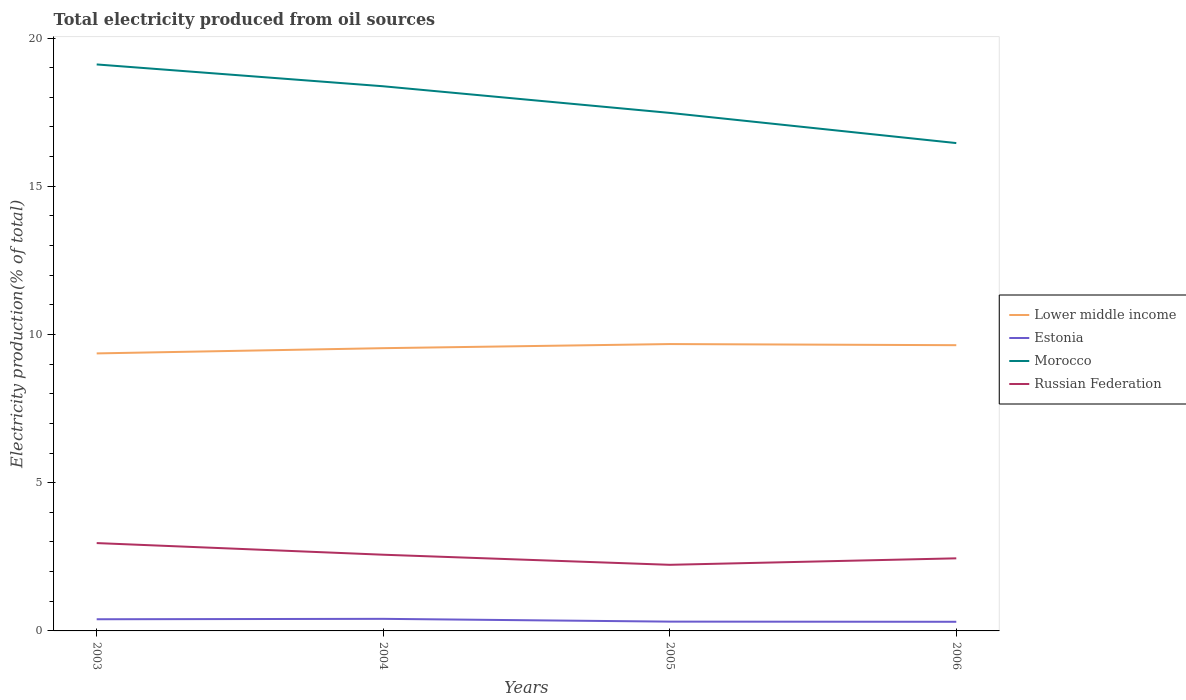Is the number of lines equal to the number of legend labels?
Offer a very short reply. Yes. Across all years, what is the maximum total electricity produced in Lower middle income?
Ensure brevity in your answer.  9.36. In which year was the total electricity produced in Estonia maximum?
Offer a terse response. 2006. What is the total total electricity produced in Russian Federation in the graph?
Ensure brevity in your answer.  -0.22. What is the difference between the highest and the second highest total electricity produced in Morocco?
Give a very brief answer. 2.65. What is the difference between the highest and the lowest total electricity produced in Morocco?
Ensure brevity in your answer.  2. Is the total electricity produced in Morocco strictly greater than the total electricity produced in Russian Federation over the years?
Your answer should be very brief. No. How many years are there in the graph?
Provide a succinct answer. 4. What is the difference between two consecutive major ticks on the Y-axis?
Provide a succinct answer. 5. Are the values on the major ticks of Y-axis written in scientific E-notation?
Keep it short and to the point. No. Does the graph contain any zero values?
Keep it short and to the point. No. Does the graph contain grids?
Provide a short and direct response. No. Where does the legend appear in the graph?
Offer a very short reply. Center right. How many legend labels are there?
Offer a very short reply. 4. What is the title of the graph?
Make the answer very short. Total electricity produced from oil sources. What is the Electricity production(% of total) in Lower middle income in 2003?
Provide a short and direct response. 9.36. What is the Electricity production(% of total) of Estonia in 2003?
Provide a short and direct response. 0.39. What is the Electricity production(% of total) of Morocco in 2003?
Offer a very short reply. 19.11. What is the Electricity production(% of total) in Russian Federation in 2003?
Make the answer very short. 2.96. What is the Electricity production(% of total) in Lower middle income in 2004?
Provide a short and direct response. 9.54. What is the Electricity production(% of total) of Estonia in 2004?
Make the answer very short. 0.41. What is the Electricity production(% of total) of Morocco in 2004?
Ensure brevity in your answer.  18.37. What is the Electricity production(% of total) in Russian Federation in 2004?
Your answer should be very brief. 2.57. What is the Electricity production(% of total) of Lower middle income in 2005?
Offer a terse response. 9.68. What is the Electricity production(% of total) of Estonia in 2005?
Your answer should be very brief. 0.31. What is the Electricity production(% of total) in Morocco in 2005?
Your answer should be compact. 17.48. What is the Electricity production(% of total) in Russian Federation in 2005?
Keep it short and to the point. 2.23. What is the Electricity production(% of total) in Lower middle income in 2006?
Your answer should be compact. 9.64. What is the Electricity production(% of total) in Estonia in 2006?
Make the answer very short. 0.31. What is the Electricity production(% of total) of Morocco in 2006?
Your response must be concise. 16.46. What is the Electricity production(% of total) of Russian Federation in 2006?
Provide a short and direct response. 2.45. Across all years, what is the maximum Electricity production(% of total) of Lower middle income?
Keep it short and to the point. 9.68. Across all years, what is the maximum Electricity production(% of total) of Estonia?
Ensure brevity in your answer.  0.41. Across all years, what is the maximum Electricity production(% of total) of Morocco?
Give a very brief answer. 19.11. Across all years, what is the maximum Electricity production(% of total) of Russian Federation?
Your answer should be compact. 2.96. Across all years, what is the minimum Electricity production(% of total) of Lower middle income?
Your response must be concise. 9.36. Across all years, what is the minimum Electricity production(% of total) in Estonia?
Your answer should be compact. 0.31. Across all years, what is the minimum Electricity production(% of total) of Morocco?
Give a very brief answer. 16.46. Across all years, what is the minimum Electricity production(% of total) of Russian Federation?
Give a very brief answer. 2.23. What is the total Electricity production(% of total) of Lower middle income in the graph?
Ensure brevity in your answer.  38.22. What is the total Electricity production(% of total) of Estonia in the graph?
Offer a very short reply. 1.42. What is the total Electricity production(% of total) in Morocco in the graph?
Make the answer very short. 71.42. What is the total Electricity production(% of total) in Russian Federation in the graph?
Your answer should be compact. 10.21. What is the difference between the Electricity production(% of total) of Lower middle income in 2003 and that in 2004?
Your answer should be compact. -0.18. What is the difference between the Electricity production(% of total) in Estonia in 2003 and that in 2004?
Provide a short and direct response. -0.01. What is the difference between the Electricity production(% of total) of Morocco in 2003 and that in 2004?
Offer a very short reply. 0.74. What is the difference between the Electricity production(% of total) in Russian Federation in 2003 and that in 2004?
Your answer should be compact. 0.39. What is the difference between the Electricity production(% of total) in Lower middle income in 2003 and that in 2005?
Give a very brief answer. -0.32. What is the difference between the Electricity production(% of total) of Estonia in 2003 and that in 2005?
Your answer should be compact. 0.08. What is the difference between the Electricity production(% of total) in Morocco in 2003 and that in 2005?
Give a very brief answer. 1.63. What is the difference between the Electricity production(% of total) of Russian Federation in 2003 and that in 2005?
Provide a succinct answer. 0.73. What is the difference between the Electricity production(% of total) in Lower middle income in 2003 and that in 2006?
Give a very brief answer. -0.28. What is the difference between the Electricity production(% of total) in Estonia in 2003 and that in 2006?
Offer a very short reply. 0.09. What is the difference between the Electricity production(% of total) of Morocco in 2003 and that in 2006?
Your answer should be very brief. 2.65. What is the difference between the Electricity production(% of total) of Russian Federation in 2003 and that in 2006?
Keep it short and to the point. 0.51. What is the difference between the Electricity production(% of total) in Lower middle income in 2004 and that in 2005?
Provide a succinct answer. -0.14. What is the difference between the Electricity production(% of total) of Estonia in 2004 and that in 2005?
Your answer should be very brief. 0.09. What is the difference between the Electricity production(% of total) in Morocco in 2004 and that in 2005?
Keep it short and to the point. 0.9. What is the difference between the Electricity production(% of total) in Russian Federation in 2004 and that in 2005?
Make the answer very short. 0.34. What is the difference between the Electricity production(% of total) in Lower middle income in 2004 and that in 2006?
Your answer should be very brief. -0.1. What is the difference between the Electricity production(% of total) in Estonia in 2004 and that in 2006?
Offer a very short reply. 0.1. What is the difference between the Electricity production(% of total) of Morocco in 2004 and that in 2006?
Your response must be concise. 1.92. What is the difference between the Electricity production(% of total) in Russian Federation in 2004 and that in 2006?
Your answer should be very brief. 0.12. What is the difference between the Electricity production(% of total) of Lower middle income in 2005 and that in 2006?
Make the answer very short. 0.04. What is the difference between the Electricity production(% of total) in Estonia in 2005 and that in 2006?
Ensure brevity in your answer.  0.01. What is the difference between the Electricity production(% of total) of Morocco in 2005 and that in 2006?
Offer a very short reply. 1.02. What is the difference between the Electricity production(% of total) in Russian Federation in 2005 and that in 2006?
Provide a short and direct response. -0.22. What is the difference between the Electricity production(% of total) in Lower middle income in 2003 and the Electricity production(% of total) in Estonia in 2004?
Ensure brevity in your answer.  8.95. What is the difference between the Electricity production(% of total) of Lower middle income in 2003 and the Electricity production(% of total) of Morocco in 2004?
Your answer should be compact. -9.01. What is the difference between the Electricity production(% of total) of Lower middle income in 2003 and the Electricity production(% of total) of Russian Federation in 2004?
Give a very brief answer. 6.79. What is the difference between the Electricity production(% of total) in Estonia in 2003 and the Electricity production(% of total) in Morocco in 2004?
Your response must be concise. -17.98. What is the difference between the Electricity production(% of total) of Estonia in 2003 and the Electricity production(% of total) of Russian Federation in 2004?
Your answer should be compact. -2.18. What is the difference between the Electricity production(% of total) of Morocco in 2003 and the Electricity production(% of total) of Russian Federation in 2004?
Ensure brevity in your answer.  16.54. What is the difference between the Electricity production(% of total) in Lower middle income in 2003 and the Electricity production(% of total) in Estonia in 2005?
Your answer should be compact. 9.05. What is the difference between the Electricity production(% of total) of Lower middle income in 2003 and the Electricity production(% of total) of Morocco in 2005?
Your answer should be compact. -8.11. What is the difference between the Electricity production(% of total) of Lower middle income in 2003 and the Electricity production(% of total) of Russian Federation in 2005?
Your answer should be compact. 7.13. What is the difference between the Electricity production(% of total) of Estonia in 2003 and the Electricity production(% of total) of Morocco in 2005?
Your response must be concise. -17.08. What is the difference between the Electricity production(% of total) of Estonia in 2003 and the Electricity production(% of total) of Russian Federation in 2005?
Your answer should be very brief. -1.84. What is the difference between the Electricity production(% of total) in Morocco in 2003 and the Electricity production(% of total) in Russian Federation in 2005?
Offer a very short reply. 16.88. What is the difference between the Electricity production(% of total) in Lower middle income in 2003 and the Electricity production(% of total) in Estonia in 2006?
Offer a very short reply. 9.05. What is the difference between the Electricity production(% of total) in Lower middle income in 2003 and the Electricity production(% of total) in Morocco in 2006?
Give a very brief answer. -7.1. What is the difference between the Electricity production(% of total) of Lower middle income in 2003 and the Electricity production(% of total) of Russian Federation in 2006?
Give a very brief answer. 6.91. What is the difference between the Electricity production(% of total) in Estonia in 2003 and the Electricity production(% of total) in Morocco in 2006?
Offer a terse response. -16.06. What is the difference between the Electricity production(% of total) of Estonia in 2003 and the Electricity production(% of total) of Russian Federation in 2006?
Provide a succinct answer. -2.06. What is the difference between the Electricity production(% of total) of Morocco in 2003 and the Electricity production(% of total) of Russian Federation in 2006?
Give a very brief answer. 16.66. What is the difference between the Electricity production(% of total) of Lower middle income in 2004 and the Electricity production(% of total) of Estonia in 2005?
Offer a terse response. 9.22. What is the difference between the Electricity production(% of total) in Lower middle income in 2004 and the Electricity production(% of total) in Morocco in 2005?
Make the answer very short. -7.94. What is the difference between the Electricity production(% of total) of Lower middle income in 2004 and the Electricity production(% of total) of Russian Federation in 2005?
Give a very brief answer. 7.31. What is the difference between the Electricity production(% of total) of Estonia in 2004 and the Electricity production(% of total) of Morocco in 2005?
Your answer should be compact. -17.07. What is the difference between the Electricity production(% of total) in Estonia in 2004 and the Electricity production(% of total) in Russian Federation in 2005?
Your response must be concise. -1.82. What is the difference between the Electricity production(% of total) in Morocco in 2004 and the Electricity production(% of total) in Russian Federation in 2005?
Ensure brevity in your answer.  16.14. What is the difference between the Electricity production(% of total) in Lower middle income in 2004 and the Electricity production(% of total) in Estonia in 2006?
Offer a terse response. 9.23. What is the difference between the Electricity production(% of total) in Lower middle income in 2004 and the Electricity production(% of total) in Morocco in 2006?
Keep it short and to the point. -6.92. What is the difference between the Electricity production(% of total) of Lower middle income in 2004 and the Electricity production(% of total) of Russian Federation in 2006?
Provide a short and direct response. 7.09. What is the difference between the Electricity production(% of total) of Estonia in 2004 and the Electricity production(% of total) of Morocco in 2006?
Provide a succinct answer. -16.05. What is the difference between the Electricity production(% of total) of Estonia in 2004 and the Electricity production(% of total) of Russian Federation in 2006?
Give a very brief answer. -2.04. What is the difference between the Electricity production(% of total) in Morocco in 2004 and the Electricity production(% of total) in Russian Federation in 2006?
Offer a terse response. 15.92. What is the difference between the Electricity production(% of total) of Lower middle income in 2005 and the Electricity production(% of total) of Estonia in 2006?
Offer a terse response. 9.37. What is the difference between the Electricity production(% of total) of Lower middle income in 2005 and the Electricity production(% of total) of Morocco in 2006?
Provide a short and direct response. -6.78. What is the difference between the Electricity production(% of total) of Lower middle income in 2005 and the Electricity production(% of total) of Russian Federation in 2006?
Your answer should be compact. 7.23. What is the difference between the Electricity production(% of total) of Estonia in 2005 and the Electricity production(% of total) of Morocco in 2006?
Your answer should be very brief. -16.14. What is the difference between the Electricity production(% of total) of Estonia in 2005 and the Electricity production(% of total) of Russian Federation in 2006?
Give a very brief answer. -2.14. What is the difference between the Electricity production(% of total) in Morocco in 2005 and the Electricity production(% of total) in Russian Federation in 2006?
Provide a short and direct response. 15.03. What is the average Electricity production(% of total) of Lower middle income per year?
Your answer should be very brief. 9.55. What is the average Electricity production(% of total) of Estonia per year?
Offer a terse response. 0.36. What is the average Electricity production(% of total) in Morocco per year?
Your response must be concise. 17.85. What is the average Electricity production(% of total) in Russian Federation per year?
Your answer should be very brief. 2.55. In the year 2003, what is the difference between the Electricity production(% of total) in Lower middle income and Electricity production(% of total) in Estonia?
Provide a succinct answer. 8.97. In the year 2003, what is the difference between the Electricity production(% of total) in Lower middle income and Electricity production(% of total) in Morocco?
Ensure brevity in your answer.  -9.75. In the year 2003, what is the difference between the Electricity production(% of total) of Lower middle income and Electricity production(% of total) of Russian Federation?
Keep it short and to the point. 6.4. In the year 2003, what is the difference between the Electricity production(% of total) of Estonia and Electricity production(% of total) of Morocco?
Offer a terse response. -18.72. In the year 2003, what is the difference between the Electricity production(% of total) in Estonia and Electricity production(% of total) in Russian Federation?
Your answer should be compact. -2.57. In the year 2003, what is the difference between the Electricity production(% of total) in Morocco and Electricity production(% of total) in Russian Federation?
Your answer should be compact. 16.15. In the year 2004, what is the difference between the Electricity production(% of total) in Lower middle income and Electricity production(% of total) in Estonia?
Offer a very short reply. 9.13. In the year 2004, what is the difference between the Electricity production(% of total) in Lower middle income and Electricity production(% of total) in Morocco?
Ensure brevity in your answer.  -8.83. In the year 2004, what is the difference between the Electricity production(% of total) in Lower middle income and Electricity production(% of total) in Russian Federation?
Give a very brief answer. 6.97. In the year 2004, what is the difference between the Electricity production(% of total) of Estonia and Electricity production(% of total) of Morocco?
Keep it short and to the point. -17.97. In the year 2004, what is the difference between the Electricity production(% of total) in Estonia and Electricity production(% of total) in Russian Federation?
Provide a succinct answer. -2.16. In the year 2004, what is the difference between the Electricity production(% of total) of Morocco and Electricity production(% of total) of Russian Federation?
Offer a very short reply. 15.8. In the year 2005, what is the difference between the Electricity production(% of total) of Lower middle income and Electricity production(% of total) of Estonia?
Offer a terse response. 9.36. In the year 2005, what is the difference between the Electricity production(% of total) in Lower middle income and Electricity production(% of total) in Morocco?
Offer a very short reply. -7.8. In the year 2005, what is the difference between the Electricity production(% of total) in Lower middle income and Electricity production(% of total) in Russian Federation?
Give a very brief answer. 7.45. In the year 2005, what is the difference between the Electricity production(% of total) of Estonia and Electricity production(% of total) of Morocco?
Ensure brevity in your answer.  -17.16. In the year 2005, what is the difference between the Electricity production(% of total) in Estonia and Electricity production(% of total) in Russian Federation?
Ensure brevity in your answer.  -1.92. In the year 2005, what is the difference between the Electricity production(% of total) in Morocco and Electricity production(% of total) in Russian Federation?
Your answer should be compact. 15.25. In the year 2006, what is the difference between the Electricity production(% of total) of Lower middle income and Electricity production(% of total) of Estonia?
Your answer should be compact. 9.33. In the year 2006, what is the difference between the Electricity production(% of total) of Lower middle income and Electricity production(% of total) of Morocco?
Provide a succinct answer. -6.82. In the year 2006, what is the difference between the Electricity production(% of total) of Lower middle income and Electricity production(% of total) of Russian Federation?
Provide a succinct answer. 7.19. In the year 2006, what is the difference between the Electricity production(% of total) in Estonia and Electricity production(% of total) in Morocco?
Offer a very short reply. -16.15. In the year 2006, what is the difference between the Electricity production(% of total) of Estonia and Electricity production(% of total) of Russian Federation?
Keep it short and to the point. -2.14. In the year 2006, what is the difference between the Electricity production(% of total) of Morocco and Electricity production(% of total) of Russian Federation?
Your answer should be compact. 14.01. What is the ratio of the Electricity production(% of total) in Lower middle income in 2003 to that in 2004?
Your answer should be very brief. 0.98. What is the ratio of the Electricity production(% of total) in Estonia in 2003 to that in 2004?
Provide a succinct answer. 0.97. What is the ratio of the Electricity production(% of total) of Morocco in 2003 to that in 2004?
Make the answer very short. 1.04. What is the ratio of the Electricity production(% of total) of Russian Federation in 2003 to that in 2004?
Give a very brief answer. 1.15. What is the ratio of the Electricity production(% of total) in Lower middle income in 2003 to that in 2005?
Offer a very short reply. 0.97. What is the ratio of the Electricity production(% of total) in Estonia in 2003 to that in 2005?
Keep it short and to the point. 1.26. What is the ratio of the Electricity production(% of total) of Morocco in 2003 to that in 2005?
Your response must be concise. 1.09. What is the ratio of the Electricity production(% of total) of Russian Federation in 2003 to that in 2005?
Keep it short and to the point. 1.33. What is the ratio of the Electricity production(% of total) in Lower middle income in 2003 to that in 2006?
Give a very brief answer. 0.97. What is the ratio of the Electricity production(% of total) of Estonia in 2003 to that in 2006?
Offer a terse response. 1.28. What is the ratio of the Electricity production(% of total) in Morocco in 2003 to that in 2006?
Your response must be concise. 1.16. What is the ratio of the Electricity production(% of total) of Russian Federation in 2003 to that in 2006?
Ensure brevity in your answer.  1.21. What is the ratio of the Electricity production(% of total) of Lower middle income in 2004 to that in 2005?
Provide a succinct answer. 0.99. What is the ratio of the Electricity production(% of total) in Estonia in 2004 to that in 2005?
Keep it short and to the point. 1.3. What is the ratio of the Electricity production(% of total) in Morocco in 2004 to that in 2005?
Keep it short and to the point. 1.05. What is the ratio of the Electricity production(% of total) in Russian Federation in 2004 to that in 2005?
Provide a succinct answer. 1.15. What is the ratio of the Electricity production(% of total) of Estonia in 2004 to that in 2006?
Make the answer very short. 1.32. What is the ratio of the Electricity production(% of total) in Morocco in 2004 to that in 2006?
Provide a short and direct response. 1.12. What is the ratio of the Electricity production(% of total) in Russian Federation in 2004 to that in 2006?
Give a very brief answer. 1.05. What is the ratio of the Electricity production(% of total) of Estonia in 2005 to that in 2006?
Your answer should be very brief. 1.02. What is the ratio of the Electricity production(% of total) of Morocco in 2005 to that in 2006?
Your answer should be compact. 1.06. What is the ratio of the Electricity production(% of total) in Russian Federation in 2005 to that in 2006?
Keep it short and to the point. 0.91. What is the difference between the highest and the second highest Electricity production(% of total) in Lower middle income?
Provide a succinct answer. 0.04. What is the difference between the highest and the second highest Electricity production(% of total) in Estonia?
Your answer should be very brief. 0.01. What is the difference between the highest and the second highest Electricity production(% of total) of Morocco?
Your answer should be compact. 0.74. What is the difference between the highest and the second highest Electricity production(% of total) in Russian Federation?
Offer a very short reply. 0.39. What is the difference between the highest and the lowest Electricity production(% of total) in Lower middle income?
Make the answer very short. 0.32. What is the difference between the highest and the lowest Electricity production(% of total) of Estonia?
Make the answer very short. 0.1. What is the difference between the highest and the lowest Electricity production(% of total) of Morocco?
Make the answer very short. 2.65. What is the difference between the highest and the lowest Electricity production(% of total) in Russian Federation?
Your response must be concise. 0.73. 